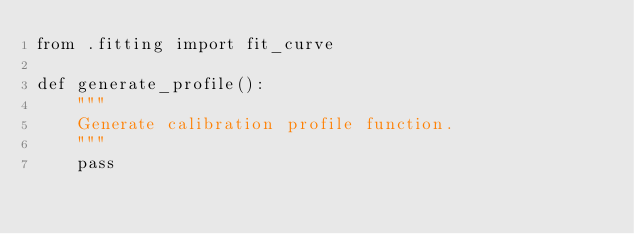<code> <loc_0><loc_0><loc_500><loc_500><_Python_>from .fitting import fit_curve

def generate_profile():
    """
    Generate calibration profile function.
    """
    pass
</code> 